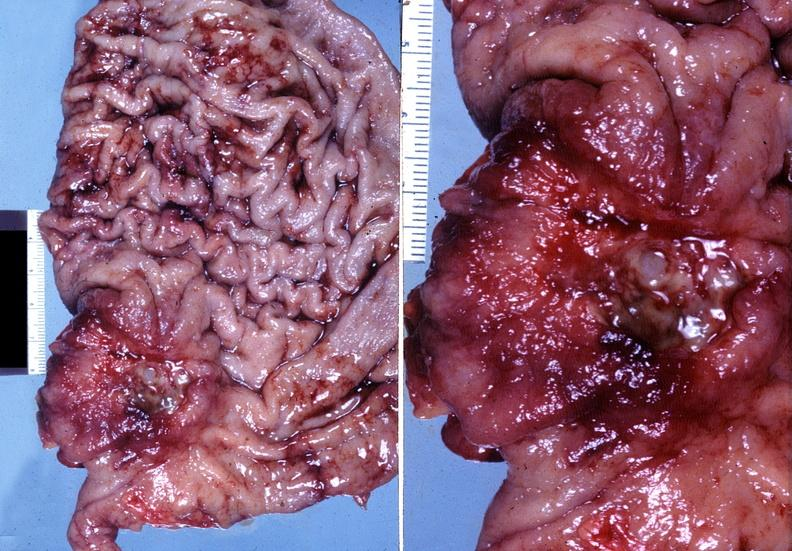s gastrointestinal present?
Answer the question using a single word or phrase. Yes 